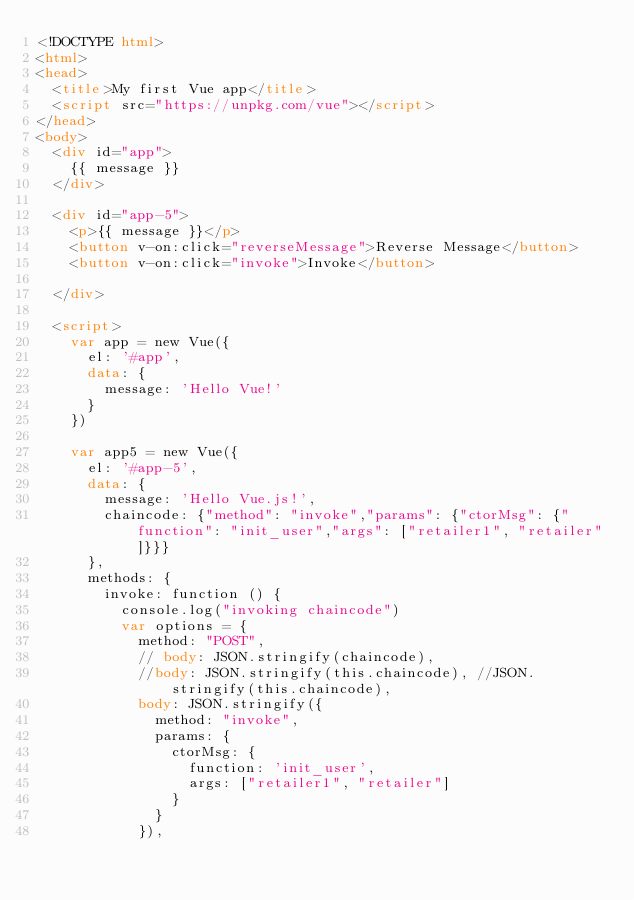<code> <loc_0><loc_0><loc_500><loc_500><_HTML_><!DOCTYPE html>
<html>
<head>
  <title>My first Vue app</title>
  <script src="https://unpkg.com/vue"></script>
</head>
<body>
  <div id="app">
    {{ message }}
  </div>

  <div id="app-5">
    <p>{{ message }}</p>
    <button v-on:click="reverseMessage">Reverse Message</button>
    <button v-on:click="invoke">Invoke</button>

  </div>

  <script>
    var app = new Vue({
      el: '#app',
      data: {
        message: 'Hello Vue!'
      }
    })

    var app5 = new Vue({
      el: '#app-5',
      data: {
        message: 'Hello Vue.js!',
        chaincode: {"method": "invoke","params": {"ctorMsg": {"function": "init_user","args": ["retailer1", "retailer"]}}}
      },
      methods: {
        invoke: function () {
          console.log("invoking chaincode")
          var options = {
            method: "POST",
            // body: JSON.stringify(chaincode),
            //body: JSON.stringify(this.chaincode), //JSON.stringify(this.chaincode),
            body: JSON.stringify({
              method: "invoke",
              params: {
                ctorMsg: {
                  function: 'init_user',
                  args: ["retailer1", "retailer"]
                }
              }
            }),</code> 